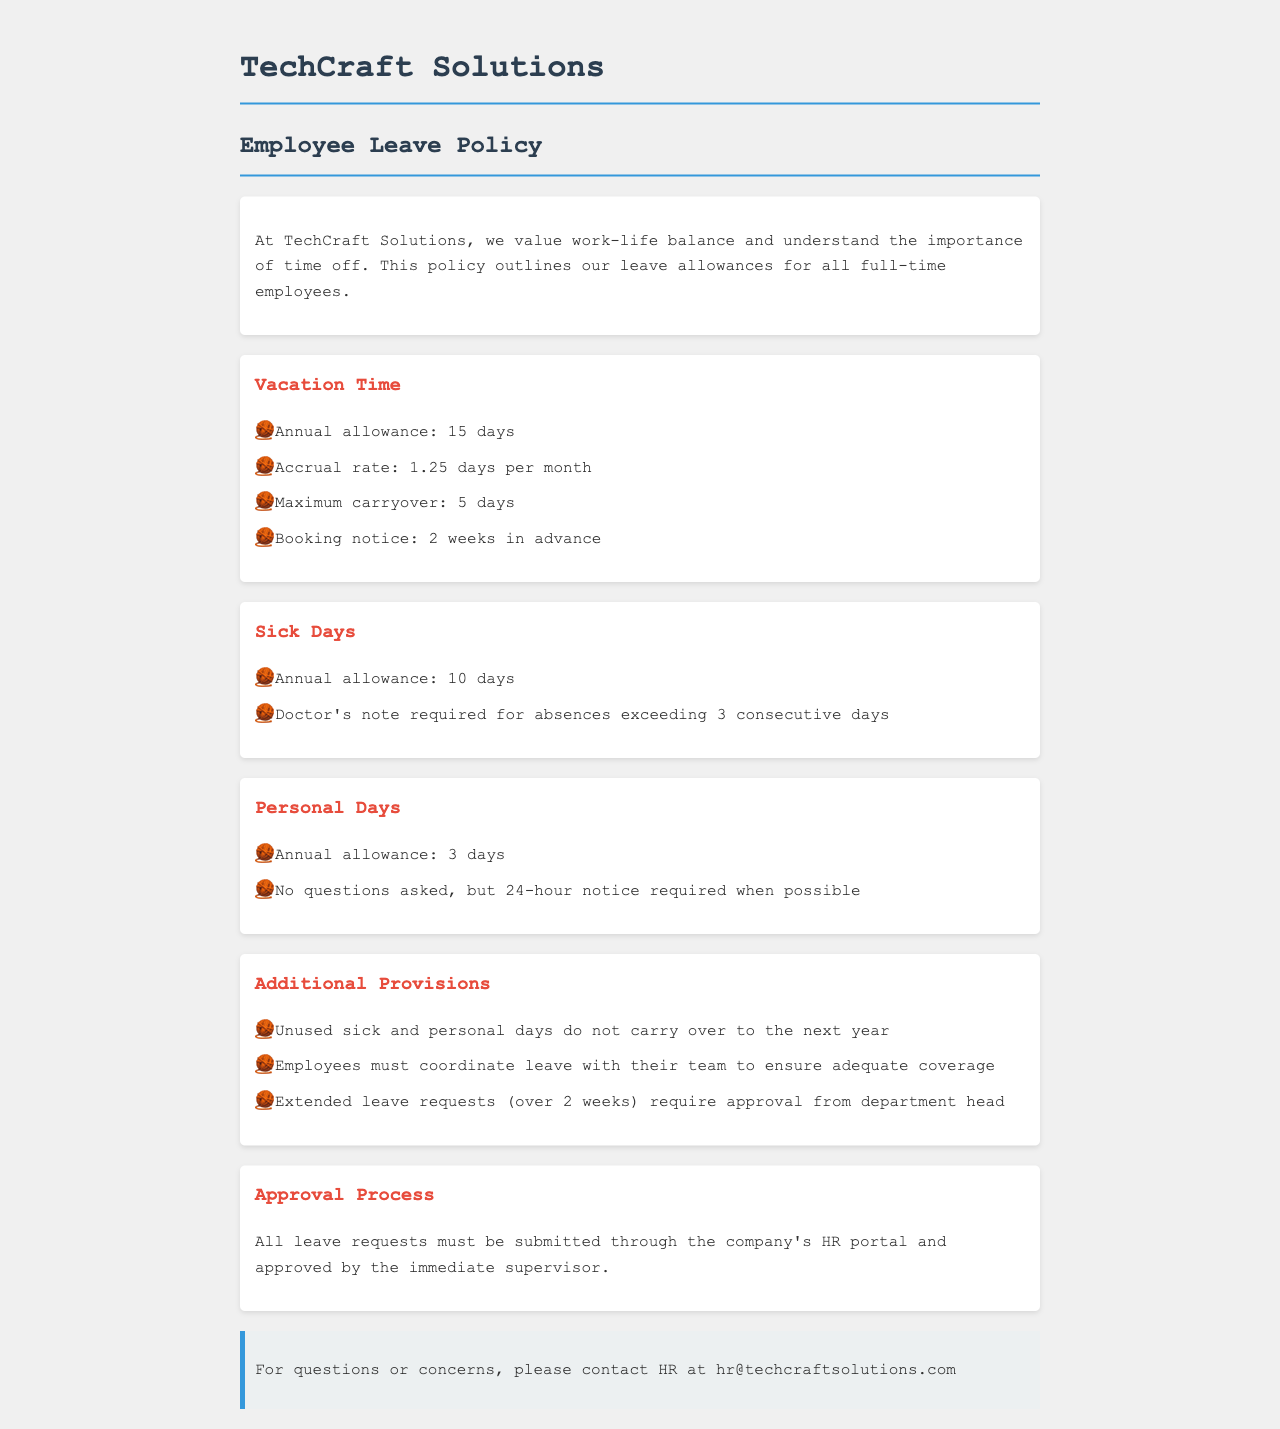What is the annual allowance for vacation time? The document specifically states that the annual allowance for vacation time is 15 days.
Answer: 15 days How many days of sick leave are allowed annually? The document indicates that the annual allowance for sick days is 10 days.
Answer: 10 days What is the maximum carryover for vacation days? According to the policy, the maximum carryover for vacation days is 5 days.
Answer: 5 days How many personal days can an employee take? The document specifies that the annual allowance for personal days is 3 days.
Answer: 3 days How long in advance should vacation time be booked? The policy mentions that booking notice for vacation time should be 2 weeks in advance.
Answer: 2 weeks Do unused sick days carry over to the next year? The document states that unused sick and personal days do not carry over to the next year.
Answer: No What is required for sick absences exceeding 3 days? The policy indicates that a doctor's note is required for sick absences exceeding 3 consecutive days.
Answer: Doctor's note Who must approve all leave requests? The document specifies that all leave requests must be approved by the immediate supervisor.
Answer: Immediate supervisor What must employees do to ensure adequate coverage during leave? The policy states that employees must coordinate leave with their team to ensure adequate coverage.
Answer: Coordinate with their team 